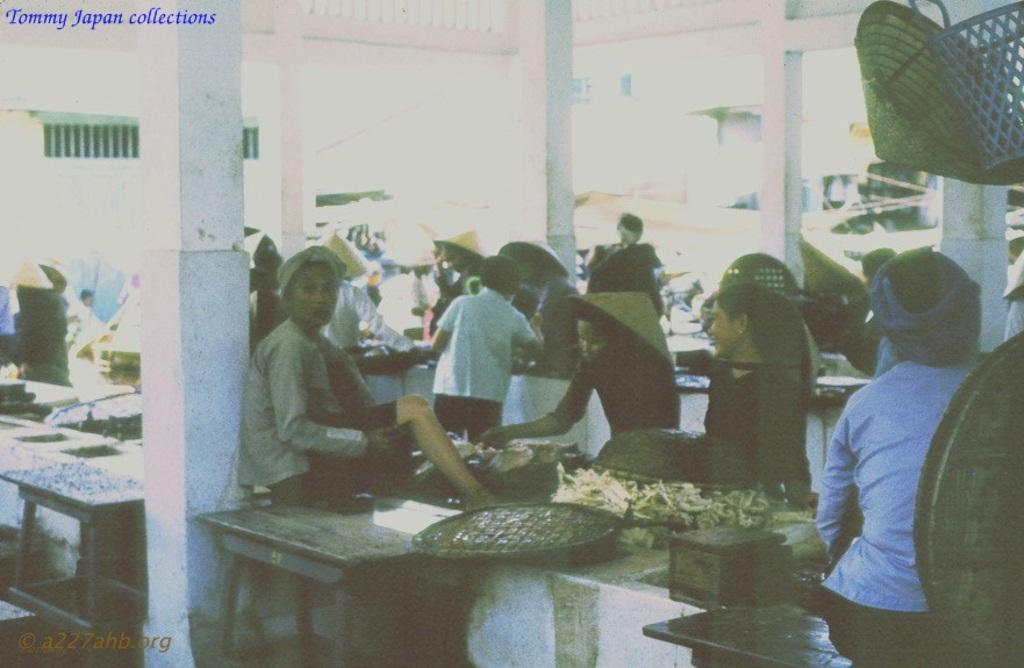How many people are in the image? There are people in the image, but the exact number is not specified. What are the people in the image doing? Some people are sitting, while others are standing. What are the people wearing on their heads? Most of the people are wearing hats. What type of beef is being served at the monkey's activity in the image? There is no mention of beef, monkeys, or any activity in the image. 